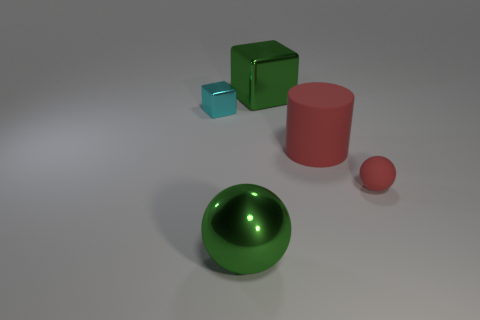There is a rubber sphere; is it the same color as the big matte cylinder that is behind the red rubber ball?
Give a very brief answer. Yes. There is a metallic sphere that is the same size as the green shiny block; what color is it?
Keep it short and to the point. Green. Is there a big gray shiny thing that has the same shape as the small metallic object?
Your response must be concise. No. Are there fewer tiny gray shiny spheres than big green spheres?
Keep it short and to the point. Yes. The matte thing that is on the right side of the large cylinder is what color?
Your answer should be very brief. Red. What shape is the metallic thing that is in front of the red object that is behind the tiny red matte sphere?
Provide a short and direct response. Sphere. Does the large cube have the same material as the small object that is to the left of the large matte thing?
Your answer should be very brief. Yes. What is the shape of the tiny object that is the same color as the cylinder?
Ensure brevity in your answer.  Sphere. How many green metal balls have the same size as the red cylinder?
Keep it short and to the point. 1. Is the number of green metal objects in front of the tiny metal thing less than the number of cyan rubber cylinders?
Your answer should be compact. No. 